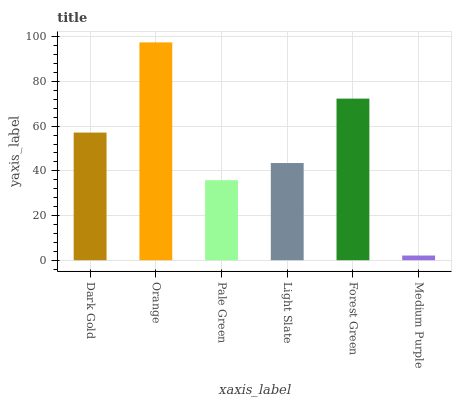Is Medium Purple the minimum?
Answer yes or no. Yes. Is Orange the maximum?
Answer yes or no. Yes. Is Pale Green the minimum?
Answer yes or no. No. Is Pale Green the maximum?
Answer yes or no. No. Is Orange greater than Pale Green?
Answer yes or no. Yes. Is Pale Green less than Orange?
Answer yes or no. Yes. Is Pale Green greater than Orange?
Answer yes or no. No. Is Orange less than Pale Green?
Answer yes or no. No. Is Dark Gold the high median?
Answer yes or no. Yes. Is Light Slate the low median?
Answer yes or no. Yes. Is Orange the high median?
Answer yes or no. No. Is Orange the low median?
Answer yes or no. No. 